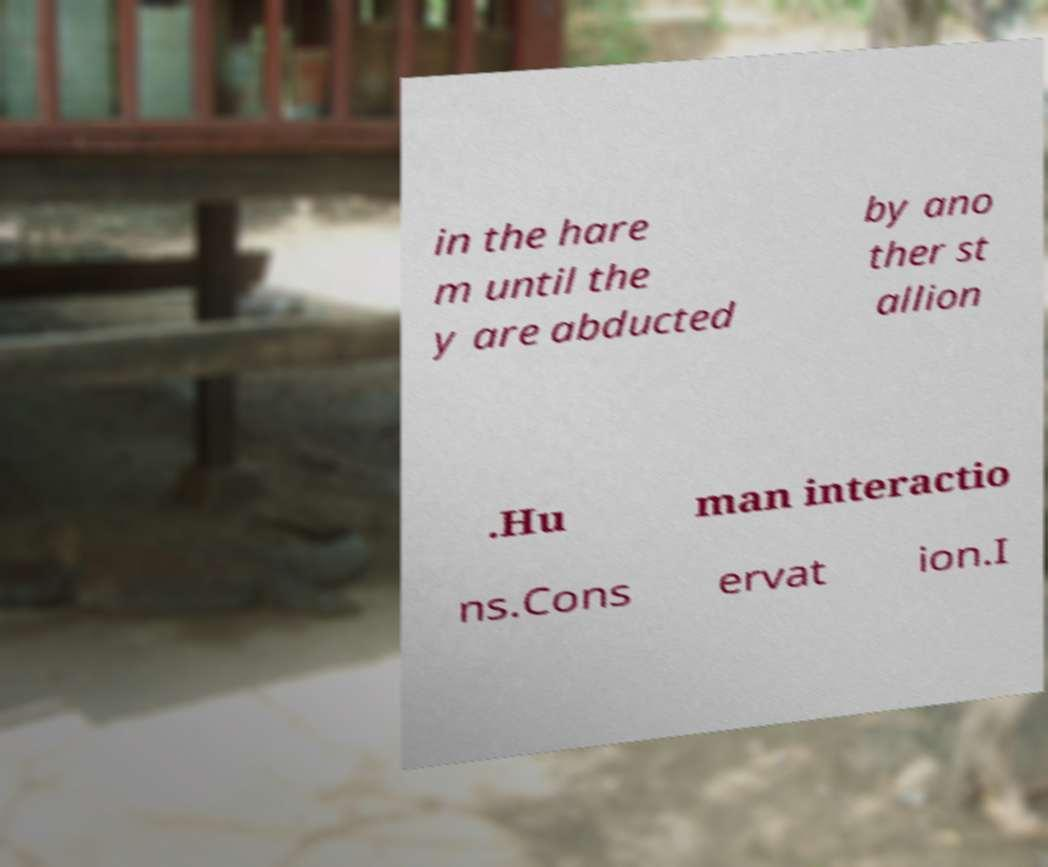Please identify and transcribe the text found in this image. in the hare m until the y are abducted by ano ther st allion .Hu man interactio ns.Cons ervat ion.I 